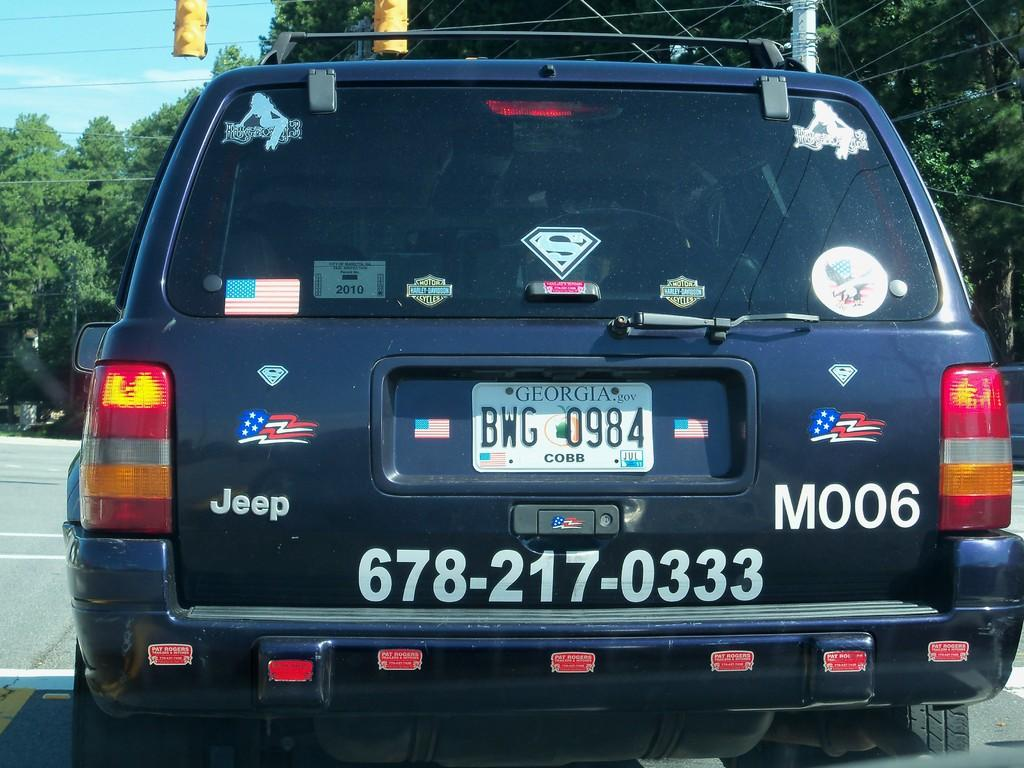What is the main subject in the foreground of the image? There is a car in the foreground of the image. What is the car doing in the image? The car is moving on the road. What can be seen in the background of the image? There are cables, trees, and the sky visible in the background of the image. What type of jelly can be seen dripping from the cables in the image? There is no jelly present in the image, and the cables are not depicted as dripping anything. 